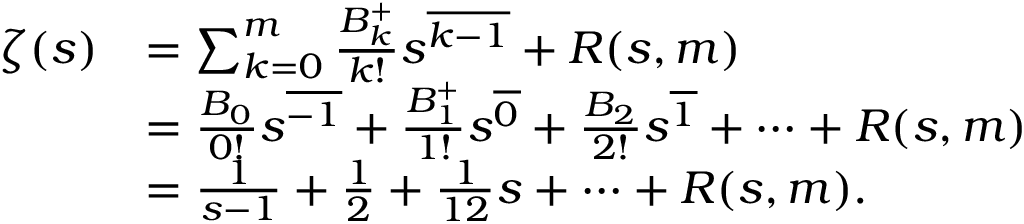<formula> <loc_0><loc_0><loc_500><loc_500>{ \begin{array} { r l } { \zeta ( s ) } & { = \sum _ { k = 0 } ^ { m } { \frac { B _ { k } ^ { + } } { k ! } } s ^ { \overline { k - 1 } } + R ( s , m ) } \\ & { = { \frac { B _ { 0 } } { 0 ! } } s ^ { \overline { - 1 } } + { \frac { B _ { 1 } ^ { + } } { 1 ! } } s ^ { \overline { 0 } } + { \frac { B _ { 2 } } { 2 ! } } s ^ { \overline { 1 } } + \cdots + R ( s , m ) } \\ & { = { \frac { 1 } { s - 1 } } + { \frac { 1 } { 2 } } + { \frac { 1 } { 1 2 } } s + \cdots + R ( s , m ) . } \end{array} }</formula> 